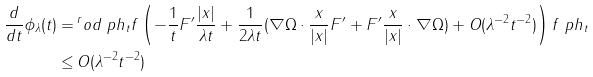<formula> <loc_0><loc_0><loc_500><loc_500>\frac { d } { d t } \phi _ { \lambda } ( t ) = \, & ^ { r } o d { \ p h _ { t } } { f \left ( - \frac { 1 } { t } F ^ { \prime } \frac { | x | } { \lambda t } + \frac { 1 } { 2 \lambda t } ( \nabla \Omega \cdot \frac { x } { | x | } F ^ { \prime } + F ^ { \prime } \frac { x } { | x | } \cdot \nabla \Omega ) + O ( \lambda ^ { - 2 } t ^ { - 2 } ) \right ) f \ p h _ { t } } \\ \leq \, & O ( \lambda ^ { - 2 } t ^ { - 2 } )</formula> 